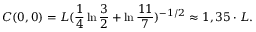<formula> <loc_0><loc_0><loc_500><loc_500>C ( 0 , 0 ) = L ( \frac { 1 } { 4 } \ln { \frac { 3 } { 2 } } + \ln { \frac { 1 1 } { 7 } } ) ^ { - 1 / 2 } \approx 1 , 3 5 \cdot L .</formula> 